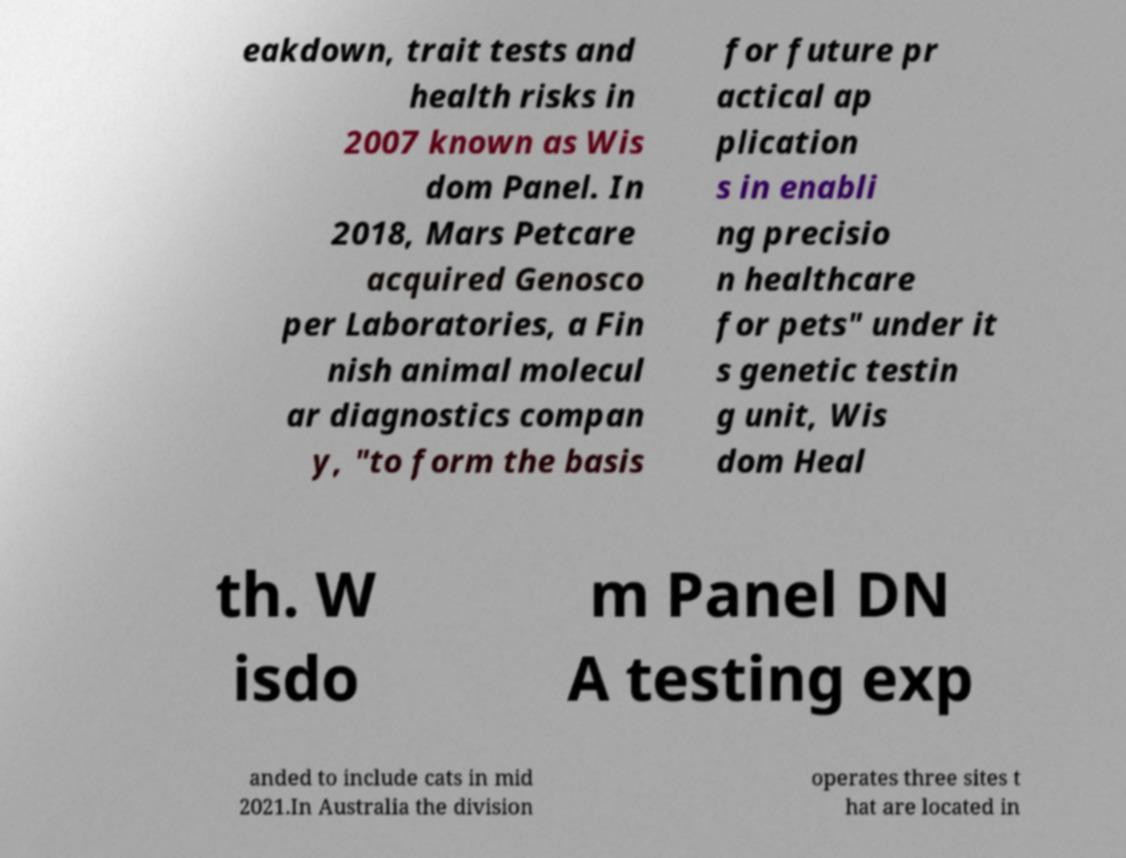Please identify and transcribe the text found in this image. eakdown, trait tests and health risks in 2007 known as Wis dom Panel. In 2018, Mars Petcare acquired Genosco per Laboratories, a Fin nish animal molecul ar diagnostics compan y, "to form the basis for future pr actical ap plication s in enabli ng precisio n healthcare for pets" under it s genetic testin g unit, Wis dom Heal th. W isdo m Panel DN A testing exp anded to include cats in mid 2021.In Australia the division operates three sites t hat are located in 